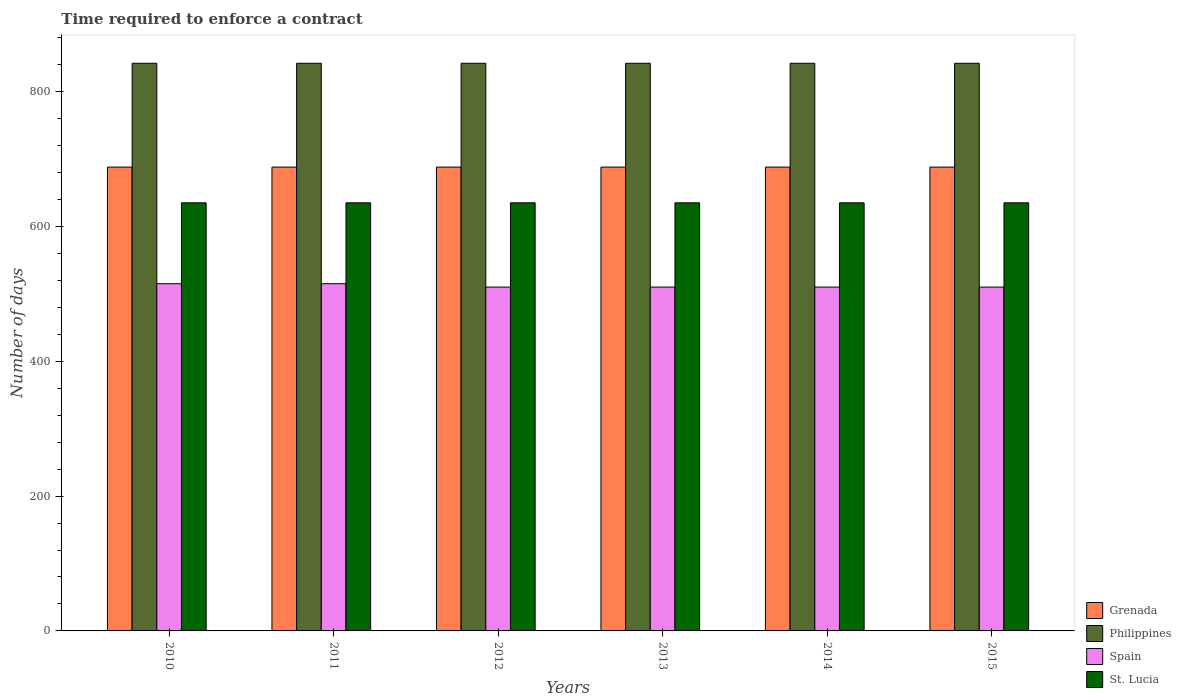How many different coloured bars are there?
Keep it short and to the point. 4. Are the number of bars on each tick of the X-axis equal?
Provide a short and direct response. Yes. What is the label of the 1st group of bars from the left?
Provide a succinct answer. 2010. What is the number of days required to enforce a contract in St. Lucia in 2012?
Your answer should be very brief. 635. Across all years, what is the maximum number of days required to enforce a contract in Spain?
Your answer should be very brief. 515. Across all years, what is the minimum number of days required to enforce a contract in Philippines?
Your answer should be very brief. 842. In which year was the number of days required to enforce a contract in St. Lucia maximum?
Offer a very short reply. 2010. In which year was the number of days required to enforce a contract in Philippines minimum?
Provide a succinct answer. 2010. What is the total number of days required to enforce a contract in Grenada in the graph?
Your response must be concise. 4128. What is the difference between the number of days required to enforce a contract in Spain in 2011 and the number of days required to enforce a contract in Philippines in 2015?
Keep it short and to the point. -327. What is the average number of days required to enforce a contract in Philippines per year?
Keep it short and to the point. 842. In the year 2013, what is the difference between the number of days required to enforce a contract in St. Lucia and number of days required to enforce a contract in Philippines?
Offer a terse response. -207. What is the ratio of the number of days required to enforce a contract in Philippines in 2012 to that in 2013?
Your response must be concise. 1. Is the difference between the number of days required to enforce a contract in St. Lucia in 2010 and 2015 greater than the difference between the number of days required to enforce a contract in Philippines in 2010 and 2015?
Offer a terse response. No. What is the difference between the highest and the second highest number of days required to enforce a contract in Philippines?
Your answer should be very brief. 0. In how many years, is the number of days required to enforce a contract in Grenada greater than the average number of days required to enforce a contract in Grenada taken over all years?
Offer a terse response. 0. Is it the case that in every year, the sum of the number of days required to enforce a contract in St. Lucia and number of days required to enforce a contract in Philippines is greater than the sum of number of days required to enforce a contract in Grenada and number of days required to enforce a contract in Spain?
Provide a succinct answer. No. What does the 1st bar from the left in 2010 represents?
Offer a terse response. Grenada. What does the 1st bar from the right in 2015 represents?
Offer a very short reply. St. Lucia. Is it the case that in every year, the sum of the number of days required to enforce a contract in Grenada and number of days required to enforce a contract in Philippines is greater than the number of days required to enforce a contract in St. Lucia?
Provide a short and direct response. Yes. Are the values on the major ticks of Y-axis written in scientific E-notation?
Provide a short and direct response. No. Does the graph contain grids?
Keep it short and to the point. No. Where does the legend appear in the graph?
Keep it short and to the point. Bottom right. How are the legend labels stacked?
Keep it short and to the point. Vertical. What is the title of the graph?
Offer a terse response. Time required to enforce a contract. Does "Myanmar" appear as one of the legend labels in the graph?
Offer a terse response. No. What is the label or title of the Y-axis?
Offer a terse response. Number of days. What is the Number of days of Grenada in 2010?
Give a very brief answer. 688. What is the Number of days in Philippines in 2010?
Provide a succinct answer. 842. What is the Number of days of Spain in 2010?
Offer a very short reply. 515. What is the Number of days in St. Lucia in 2010?
Offer a very short reply. 635. What is the Number of days of Grenada in 2011?
Provide a succinct answer. 688. What is the Number of days in Philippines in 2011?
Make the answer very short. 842. What is the Number of days of Spain in 2011?
Make the answer very short. 515. What is the Number of days of St. Lucia in 2011?
Your response must be concise. 635. What is the Number of days in Grenada in 2012?
Keep it short and to the point. 688. What is the Number of days of Philippines in 2012?
Ensure brevity in your answer.  842. What is the Number of days in Spain in 2012?
Ensure brevity in your answer.  510. What is the Number of days in St. Lucia in 2012?
Offer a terse response. 635. What is the Number of days of Grenada in 2013?
Your answer should be compact. 688. What is the Number of days of Philippines in 2013?
Give a very brief answer. 842. What is the Number of days in Spain in 2013?
Give a very brief answer. 510. What is the Number of days in St. Lucia in 2013?
Give a very brief answer. 635. What is the Number of days in Grenada in 2014?
Your answer should be very brief. 688. What is the Number of days of Philippines in 2014?
Your answer should be compact. 842. What is the Number of days in Spain in 2014?
Provide a succinct answer. 510. What is the Number of days of St. Lucia in 2014?
Provide a short and direct response. 635. What is the Number of days of Grenada in 2015?
Make the answer very short. 688. What is the Number of days of Philippines in 2015?
Provide a short and direct response. 842. What is the Number of days in Spain in 2015?
Offer a very short reply. 510. What is the Number of days of St. Lucia in 2015?
Your response must be concise. 635. Across all years, what is the maximum Number of days of Grenada?
Provide a short and direct response. 688. Across all years, what is the maximum Number of days of Philippines?
Your answer should be compact. 842. Across all years, what is the maximum Number of days in Spain?
Offer a terse response. 515. Across all years, what is the maximum Number of days in St. Lucia?
Provide a succinct answer. 635. Across all years, what is the minimum Number of days of Grenada?
Offer a very short reply. 688. Across all years, what is the minimum Number of days of Philippines?
Offer a very short reply. 842. Across all years, what is the minimum Number of days in Spain?
Ensure brevity in your answer.  510. Across all years, what is the minimum Number of days in St. Lucia?
Ensure brevity in your answer.  635. What is the total Number of days in Grenada in the graph?
Provide a short and direct response. 4128. What is the total Number of days in Philippines in the graph?
Ensure brevity in your answer.  5052. What is the total Number of days in Spain in the graph?
Provide a short and direct response. 3070. What is the total Number of days of St. Lucia in the graph?
Give a very brief answer. 3810. What is the difference between the Number of days of Grenada in 2010 and that in 2011?
Your response must be concise. 0. What is the difference between the Number of days of Philippines in 2010 and that in 2011?
Give a very brief answer. 0. What is the difference between the Number of days of Spain in 2010 and that in 2011?
Offer a very short reply. 0. What is the difference between the Number of days of Grenada in 2010 and that in 2012?
Your response must be concise. 0. What is the difference between the Number of days in Philippines in 2010 and that in 2012?
Keep it short and to the point. 0. What is the difference between the Number of days in Spain in 2010 and that in 2012?
Make the answer very short. 5. What is the difference between the Number of days of St. Lucia in 2010 and that in 2012?
Ensure brevity in your answer.  0. What is the difference between the Number of days of St. Lucia in 2010 and that in 2013?
Your answer should be very brief. 0. What is the difference between the Number of days of Philippines in 2010 and that in 2014?
Provide a succinct answer. 0. What is the difference between the Number of days of Philippines in 2011 and that in 2012?
Ensure brevity in your answer.  0. What is the difference between the Number of days of Spain in 2011 and that in 2012?
Your answer should be compact. 5. What is the difference between the Number of days of Grenada in 2011 and that in 2013?
Provide a short and direct response. 0. What is the difference between the Number of days of Spain in 2011 and that in 2013?
Give a very brief answer. 5. What is the difference between the Number of days in Grenada in 2011 and that in 2014?
Provide a succinct answer. 0. What is the difference between the Number of days of Grenada in 2011 and that in 2015?
Your answer should be compact. 0. What is the difference between the Number of days in Philippines in 2011 and that in 2015?
Provide a succinct answer. 0. What is the difference between the Number of days in St. Lucia in 2011 and that in 2015?
Provide a short and direct response. 0. What is the difference between the Number of days of Grenada in 2012 and that in 2013?
Provide a short and direct response. 0. What is the difference between the Number of days in St. Lucia in 2012 and that in 2014?
Provide a short and direct response. 0. What is the difference between the Number of days in Philippines in 2012 and that in 2015?
Offer a terse response. 0. What is the difference between the Number of days of Spain in 2012 and that in 2015?
Offer a terse response. 0. What is the difference between the Number of days of Grenada in 2013 and that in 2014?
Make the answer very short. 0. What is the difference between the Number of days in Philippines in 2013 and that in 2014?
Offer a terse response. 0. What is the difference between the Number of days of Spain in 2013 and that in 2014?
Offer a terse response. 0. What is the difference between the Number of days in St. Lucia in 2013 and that in 2014?
Make the answer very short. 0. What is the difference between the Number of days of Philippines in 2013 and that in 2015?
Make the answer very short. 0. What is the difference between the Number of days of Spain in 2013 and that in 2015?
Offer a very short reply. 0. What is the difference between the Number of days in Philippines in 2014 and that in 2015?
Offer a very short reply. 0. What is the difference between the Number of days of St. Lucia in 2014 and that in 2015?
Your response must be concise. 0. What is the difference between the Number of days of Grenada in 2010 and the Number of days of Philippines in 2011?
Your answer should be compact. -154. What is the difference between the Number of days in Grenada in 2010 and the Number of days in Spain in 2011?
Give a very brief answer. 173. What is the difference between the Number of days in Philippines in 2010 and the Number of days in Spain in 2011?
Provide a succinct answer. 327. What is the difference between the Number of days in Philippines in 2010 and the Number of days in St. Lucia in 2011?
Your response must be concise. 207. What is the difference between the Number of days in Spain in 2010 and the Number of days in St. Lucia in 2011?
Your response must be concise. -120. What is the difference between the Number of days of Grenada in 2010 and the Number of days of Philippines in 2012?
Ensure brevity in your answer.  -154. What is the difference between the Number of days in Grenada in 2010 and the Number of days in Spain in 2012?
Offer a terse response. 178. What is the difference between the Number of days in Philippines in 2010 and the Number of days in Spain in 2012?
Ensure brevity in your answer.  332. What is the difference between the Number of days in Philippines in 2010 and the Number of days in St. Lucia in 2012?
Offer a terse response. 207. What is the difference between the Number of days of Spain in 2010 and the Number of days of St. Lucia in 2012?
Your response must be concise. -120. What is the difference between the Number of days in Grenada in 2010 and the Number of days in Philippines in 2013?
Provide a succinct answer. -154. What is the difference between the Number of days of Grenada in 2010 and the Number of days of Spain in 2013?
Provide a short and direct response. 178. What is the difference between the Number of days in Philippines in 2010 and the Number of days in Spain in 2013?
Your response must be concise. 332. What is the difference between the Number of days in Philippines in 2010 and the Number of days in St. Lucia in 2013?
Give a very brief answer. 207. What is the difference between the Number of days of Spain in 2010 and the Number of days of St. Lucia in 2013?
Keep it short and to the point. -120. What is the difference between the Number of days in Grenada in 2010 and the Number of days in Philippines in 2014?
Your answer should be very brief. -154. What is the difference between the Number of days in Grenada in 2010 and the Number of days in Spain in 2014?
Give a very brief answer. 178. What is the difference between the Number of days of Philippines in 2010 and the Number of days of Spain in 2014?
Your answer should be compact. 332. What is the difference between the Number of days in Philippines in 2010 and the Number of days in St. Lucia in 2014?
Your answer should be very brief. 207. What is the difference between the Number of days of Spain in 2010 and the Number of days of St. Lucia in 2014?
Keep it short and to the point. -120. What is the difference between the Number of days of Grenada in 2010 and the Number of days of Philippines in 2015?
Offer a very short reply. -154. What is the difference between the Number of days in Grenada in 2010 and the Number of days in Spain in 2015?
Provide a succinct answer. 178. What is the difference between the Number of days in Philippines in 2010 and the Number of days in Spain in 2015?
Provide a succinct answer. 332. What is the difference between the Number of days of Philippines in 2010 and the Number of days of St. Lucia in 2015?
Your response must be concise. 207. What is the difference between the Number of days in Spain in 2010 and the Number of days in St. Lucia in 2015?
Provide a short and direct response. -120. What is the difference between the Number of days of Grenada in 2011 and the Number of days of Philippines in 2012?
Make the answer very short. -154. What is the difference between the Number of days of Grenada in 2011 and the Number of days of Spain in 2012?
Your answer should be very brief. 178. What is the difference between the Number of days in Grenada in 2011 and the Number of days in St. Lucia in 2012?
Offer a very short reply. 53. What is the difference between the Number of days in Philippines in 2011 and the Number of days in Spain in 2012?
Provide a short and direct response. 332. What is the difference between the Number of days of Philippines in 2011 and the Number of days of St. Lucia in 2012?
Ensure brevity in your answer.  207. What is the difference between the Number of days of Spain in 2011 and the Number of days of St. Lucia in 2012?
Your answer should be compact. -120. What is the difference between the Number of days of Grenada in 2011 and the Number of days of Philippines in 2013?
Your answer should be compact. -154. What is the difference between the Number of days of Grenada in 2011 and the Number of days of Spain in 2013?
Keep it short and to the point. 178. What is the difference between the Number of days in Philippines in 2011 and the Number of days in Spain in 2013?
Your answer should be very brief. 332. What is the difference between the Number of days in Philippines in 2011 and the Number of days in St. Lucia in 2013?
Your answer should be very brief. 207. What is the difference between the Number of days in Spain in 2011 and the Number of days in St. Lucia in 2013?
Keep it short and to the point. -120. What is the difference between the Number of days of Grenada in 2011 and the Number of days of Philippines in 2014?
Your response must be concise. -154. What is the difference between the Number of days of Grenada in 2011 and the Number of days of Spain in 2014?
Your response must be concise. 178. What is the difference between the Number of days of Grenada in 2011 and the Number of days of St. Lucia in 2014?
Make the answer very short. 53. What is the difference between the Number of days in Philippines in 2011 and the Number of days in Spain in 2014?
Provide a succinct answer. 332. What is the difference between the Number of days in Philippines in 2011 and the Number of days in St. Lucia in 2014?
Offer a terse response. 207. What is the difference between the Number of days in Spain in 2011 and the Number of days in St. Lucia in 2014?
Provide a succinct answer. -120. What is the difference between the Number of days of Grenada in 2011 and the Number of days of Philippines in 2015?
Ensure brevity in your answer.  -154. What is the difference between the Number of days in Grenada in 2011 and the Number of days in Spain in 2015?
Offer a very short reply. 178. What is the difference between the Number of days of Grenada in 2011 and the Number of days of St. Lucia in 2015?
Your answer should be compact. 53. What is the difference between the Number of days in Philippines in 2011 and the Number of days in Spain in 2015?
Provide a short and direct response. 332. What is the difference between the Number of days in Philippines in 2011 and the Number of days in St. Lucia in 2015?
Make the answer very short. 207. What is the difference between the Number of days in Spain in 2011 and the Number of days in St. Lucia in 2015?
Ensure brevity in your answer.  -120. What is the difference between the Number of days of Grenada in 2012 and the Number of days of Philippines in 2013?
Offer a terse response. -154. What is the difference between the Number of days in Grenada in 2012 and the Number of days in Spain in 2013?
Offer a terse response. 178. What is the difference between the Number of days of Grenada in 2012 and the Number of days of St. Lucia in 2013?
Your response must be concise. 53. What is the difference between the Number of days of Philippines in 2012 and the Number of days of Spain in 2013?
Keep it short and to the point. 332. What is the difference between the Number of days in Philippines in 2012 and the Number of days in St. Lucia in 2013?
Give a very brief answer. 207. What is the difference between the Number of days of Spain in 2012 and the Number of days of St. Lucia in 2013?
Offer a terse response. -125. What is the difference between the Number of days of Grenada in 2012 and the Number of days of Philippines in 2014?
Your response must be concise. -154. What is the difference between the Number of days in Grenada in 2012 and the Number of days in Spain in 2014?
Provide a short and direct response. 178. What is the difference between the Number of days of Philippines in 2012 and the Number of days of Spain in 2014?
Give a very brief answer. 332. What is the difference between the Number of days of Philippines in 2012 and the Number of days of St. Lucia in 2014?
Offer a terse response. 207. What is the difference between the Number of days in Spain in 2012 and the Number of days in St. Lucia in 2014?
Provide a succinct answer. -125. What is the difference between the Number of days of Grenada in 2012 and the Number of days of Philippines in 2015?
Keep it short and to the point. -154. What is the difference between the Number of days of Grenada in 2012 and the Number of days of Spain in 2015?
Give a very brief answer. 178. What is the difference between the Number of days of Philippines in 2012 and the Number of days of Spain in 2015?
Provide a short and direct response. 332. What is the difference between the Number of days in Philippines in 2012 and the Number of days in St. Lucia in 2015?
Your answer should be very brief. 207. What is the difference between the Number of days of Spain in 2012 and the Number of days of St. Lucia in 2015?
Give a very brief answer. -125. What is the difference between the Number of days of Grenada in 2013 and the Number of days of Philippines in 2014?
Provide a succinct answer. -154. What is the difference between the Number of days in Grenada in 2013 and the Number of days in Spain in 2014?
Your response must be concise. 178. What is the difference between the Number of days of Philippines in 2013 and the Number of days of Spain in 2014?
Offer a terse response. 332. What is the difference between the Number of days in Philippines in 2013 and the Number of days in St. Lucia in 2014?
Make the answer very short. 207. What is the difference between the Number of days of Spain in 2013 and the Number of days of St. Lucia in 2014?
Your answer should be very brief. -125. What is the difference between the Number of days in Grenada in 2013 and the Number of days in Philippines in 2015?
Your answer should be compact. -154. What is the difference between the Number of days in Grenada in 2013 and the Number of days in Spain in 2015?
Make the answer very short. 178. What is the difference between the Number of days in Grenada in 2013 and the Number of days in St. Lucia in 2015?
Ensure brevity in your answer.  53. What is the difference between the Number of days in Philippines in 2013 and the Number of days in Spain in 2015?
Keep it short and to the point. 332. What is the difference between the Number of days of Philippines in 2013 and the Number of days of St. Lucia in 2015?
Provide a succinct answer. 207. What is the difference between the Number of days of Spain in 2013 and the Number of days of St. Lucia in 2015?
Keep it short and to the point. -125. What is the difference between the Number of days in Grenada in 2014 and the Number of days in Philippines in 2015?
Give a very brief answer. -154. What is the difference between the Number of days of Grenada in 2014 and the Number of days of Spain in 2015?
Your answer should be very brief. 178. What is the difference between the Number of days in Grenada in 2014 and the Number of days in St. Lucia in 2015?
Offer a very short reply. 53. What is the difference between the Number of days of Philippines in 2014 and the Number of days of Spain in 2015?
Ensure brevity in your answer.  332. What is the difference between the Number of days in Philippines in 2014 and the Number of days in St. Lucia in 2015?
Provide a short and direct response. 207. What is the difference between the Number of days in Spain in 2014 and the Number of days in St. Lucia in 2015?
Your response must be concise. -125. What is the average Number of days in Grenada per year?
Make the answer very short. 688. What is the average Number of days of Philippines per year?
Give a very brief answer. 842. What is the average Number of days of Spain per year?
Provide a short and direct response. 511.67. What is the average Number of days of St. Lucia per year?
Your answer should be compact. 635. In the year 2010, what is the difference between the Number of days of Grenada and Number of days of Philippines?
Give a very brief answer. -154. In the year 2010, what is the difference between the Number of days in Grenada and Number of days in Spain?
Provide a succinct answer. 173. In the year 2010, what is the difference between the Number of days in Philippines and Number of days in Spain?
Your answer should be compact. 327. In the year 2010, what is the difference between the Number of days in Philippines and Number of days in St. Lucia?
Provide a short and direct response. 207. In the year 2010, what is the difference between the Number of days of Spain and Number of days of St. Lucia?
Give a very brief answer. -120. In the year 2011, what is the difference between the Number of days of Grenada and Number of days of Philippines?
Your response must be concise. -154. In the year 2011, what is the difference between the Number of days in Grenada and Number of days in Spain?
Keep it short and to the point. 173. In the year 2011, what is the difference between the Number of days of Philippines and Number of days of Spain?
Your answer should be very brief. 327. In the year 2011, what is the difference between the Number of days in Philippines and Number of days in St. Lucia?
Keep it short and to the point. 207. In the year 2011, what is the difference between the Number of days of Spain and Number of days of St. Lucia?
Keep it short and to the point. -120. In the year 2012, what is the difference between the Number of days of Grenada and Number of days of Philippines?
Your response must be concise. -154. In the year 2012, what is the difference between the Number of days in Grenada and Number of days in Spain?
Your answer should be compact. 178. In the year 2012, what is the difference between the Number of days in Grenada and Number of days in St. Lucia?
Your answer should be very brief. 53. In the year 2012, what is the difference between the Number of days of Philippines and Number of days of Spain?
Offer a very short reply. 332. In the year 2012, what is the difference between the Number of days of Philippines and Number of days of St. Lucia?
Your answer should be compact. 207. In the year 2012, what is the difference between the Number of days in Spain and Number of days in St. Lucia?
Give a very brief answer. -125. In the year 2013, what is the difference between the Number of days of Grenada and Number of days of Philippines?
Make the answer very short. -154. In the year 2013, what is the difference between the Number of days in Grenada and Number of days in Spain?
Give a very brief answer. 178. In the year 2013, what is the difference between the Number of days in Philippines and Number of days in Spain?
Give a very brief answer. 332. In the year 2013, what is the difference between the Number of days of Philippines and Number of days of St. Lucia?
Your answer should be very brief. 207. In the year 2013, what is the difference between the Number of days in Spain and Number of days in St. Lucia?
Ensure brevity in your answer.  -125. In the year 2014, what is the difference between the Number of days of Grenada and Number of days of Philippines?
Ensure brevity in your answer.  -154. In the year 2014, what is the difference between the Number of days in Grenada and Number of days in Spain?
Give a very brief answer. 178. In the year 2014, what is the difference between the Number of days in Grenada and Number of days in St. Lucia?
Offer a very short reply. 53. In the year 2014, what is the difference between the Number of days in Philippines and Number of days in Spain?
Give a very brief answer. 332. In the year 2014, what is the difference between the Number of days in Philippines and Number of days in St. Lucia?
Your answer should be compact. 207. In the year 2014, what is the difference between the Number of days of Spain and Number of days of St. Lucia?
Make the answer very short. -125. In the year 2015, what is the difference between the Number of days of Grenada and Number of days of Philippines?
Provide a short and direct response. -154. In the year 2015, what is the difference between the Number of days in Grenada and Number of days in Spain?
Provide a succinct answer. 178. In the year 2015, what is the difference between the Number of days of Grenada and Number of days of St. Lucia?
Offer a terse response. 53. In the year 2015, what is the difference between the Number of days of Philippines and Number of days of Spain?
Give a very brief answer. 332. In the year 2015, what is the difference between the Number of days of Philippines and Number of days of St. Lucia?
Your answer should be compact. 207. In the year 2015, what is the difference between the Number of days in Spain and Number of days in St. Lucia?
Your answer should be very brief. -125. What is the ratio of the Number of days in Grenada in 2010 to that in 2011?
Give a very brief answer. 1. What is the ratio of the Number of days of Spain in 2010 to that in 2011?
Give a very brief answer. 1. What is the ratio of the Number of days in St. Lucia in 2010 to that in 2011?
Keep it short and to the point. 1. What is the ratio of the Number of days in Grenada in 2010 to that in 2012?
Offer a very short reply. 1. What is the ratio of the Number of days of Spain in 2010 to that in 2012?
Offer a very short reply. 1.01. What is the ratio of the Number of days in St. Lucia in 2010 to that in 2012?
Provide a short and direct response. 1. What is the ratio of the Number of days in Grenada in 2010 to that in 2013?
Your answer should be very brief. 1. What is the ratio of the Number of days of Spain in 2010 to that in 2013?
Offer a terse response. 1.01. What is the ratio of the Number of days in Grenada in 2010 to that in 2014?
Keep it short and to the point. 1. What is the ratio of the Number of days of Philippines in 2010 to that in 2014?
Give a very brief answer. 1. What is the ratio of the Number of days of Spain in 2010 to that in 2014?
Your answer should be very brief. 1.01. What is the ratio of the Number of days in Grenada in 2010 to that in 2015?
Make the answer very short. 1. What is the ratio of the Number of days of Spain in 2010 to that in 2015?
Keep it short and to the point. 1.01. What is the ratio of the Number of days of St. Lucia in 2010 to that in 2015?
Give a very brief answer. 1. What is the ratio of the Number of days in Philippines in 2011 to that in 2012?
Keep it short and to the point. 1. What is the ratio of the Number of days of Spain in 2011 to that in 2012?
Make the answer very short. 1.01. What is the ratio of the Number of days of Spain in 2011 to that in 2013?
Your answer should be very brief. 1.01. What is the ratio of the Number of days in St. Lucia in 2011 to that in 2013?
Provide a succinct answer. 1. What is the ratio of the Number of days in Grenada in 2011 to that in 2014?
Your answer should be very brief. 1. What is the ratio of the Number of days of Philippines in 2011 to that in 2014?
Your response must be concise. 1. What is the ratio of the Number of days in Spain in 2011 to that in 2014?
Make the answer very short. 1.01. What is the ratio of the Number of days of St. Lucia in 2011 to that in 2014?
Give a very brief answer. 1. What is the ratio of the Number of days in Grenada in 2011 to that in 2015?
Give a very brief answer. 1. What is the ratio of the Number of days of Spain in 2011 to that in 2015?
Offer a very short reply. 1.01. What is the ratio of the Number of days in St. Lucia in 2011 to that in 2015?
Your answer should be very brief. 1. What is the ratio of the Number of days in Grenada in 2012 to that in 2013?
Keep it short and to the point. 1. What is the ratio of the Number of days in Philippines in 2012 to that in 2013?
Offer a terse response. 1. What is the ratio of the Number of days of Grenada in 2012 to that in 2014?
Make the answer very short. 1. What is the ratio of the Number of days in Philippines in 2012 to that in 2014?
Your answer should be very brief. 1. What is the ratio of the Number of days in Spain in 2012 to that in 2014?
Your response must be concise. 1. What is the ratio of the Number of days of Philippines in 2012 to that in 2015?
Offer a very short reply. 1. What is the ratio of the Number of days of Grenada in 2013 to that in 2014?
Your answer should be very brief. 1. What is the ratio of the Number of days in St. Lucia in 2013 to that in 2014?
Ensure brevity in your answer.  1. What is the ratio of the Number of days of St. Lucia in 2013 to that in 2015?
Make the answer very short. 1. What is the ratio of the Number of days of Grenada in 2014 to that in 2015?
Offer a very short reply. 1. What is the ratio of the Number of days in Spain in 2014 to that in 2015?
Your answer should be very brief. 1. What is the difference between the highest and the second highest Number of days of Philippines?
Give a very brief answer. 0. What is the difference between the highest and the second highest Number of days of Spain?
Your response must be concise. 0. What is the difference between the highest and the second highest Number of days of St. Lucia?
Offer a terse response. 0. What is the difference between the highest and the lowest Number of days in Philippines?
Provide a succinct answer. 0. What is the difference between the highest and the lowest Number of days of Spain?
Ensure brevity in your answer.  5. What is the difference between the highest and the lowest Number of days of St. Lucia?
Offer a very short reply. 0. 